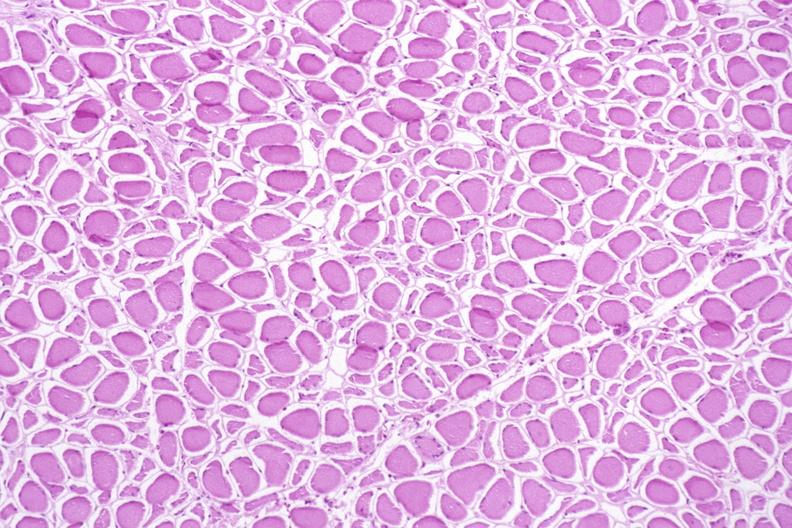s musculoskeletal present?
Answer the question using a single word or phrase. Yes 